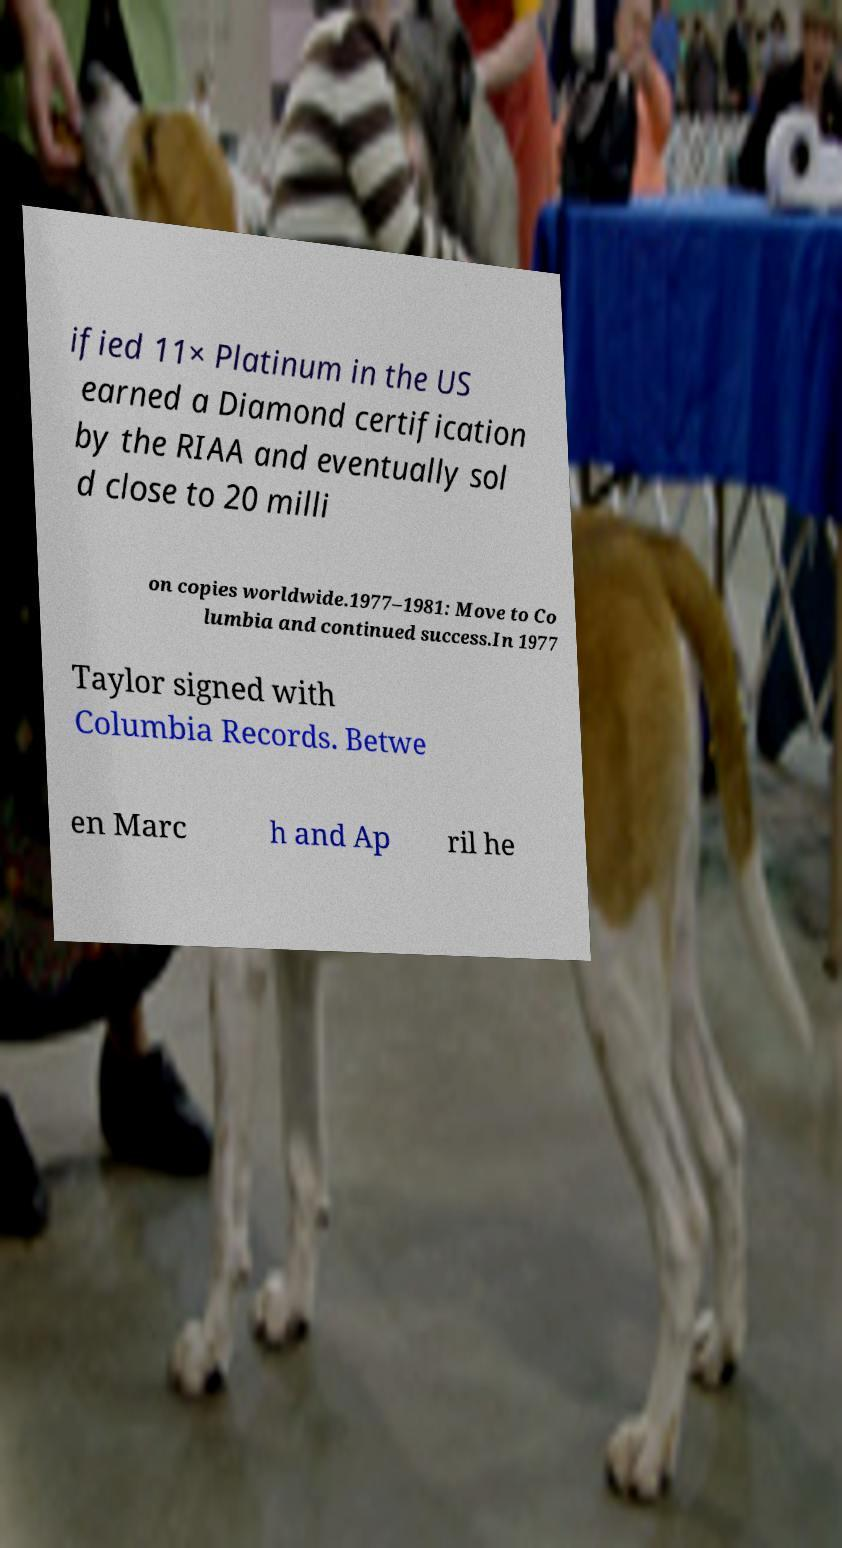Can you read and provide the text displayed in the image?This photo seems to have some interesting text. Can you extract and type it out for me? ified 11× Platinum in the US earned a Diamond certification by the RIAA and eventually sol d close to 20 milli on copies worldwide.1977–1981: Move to Co lumbia and continued success.In 1977 Taylor signed with Columbia Records. Betwe en Marc h and Ap ril he 